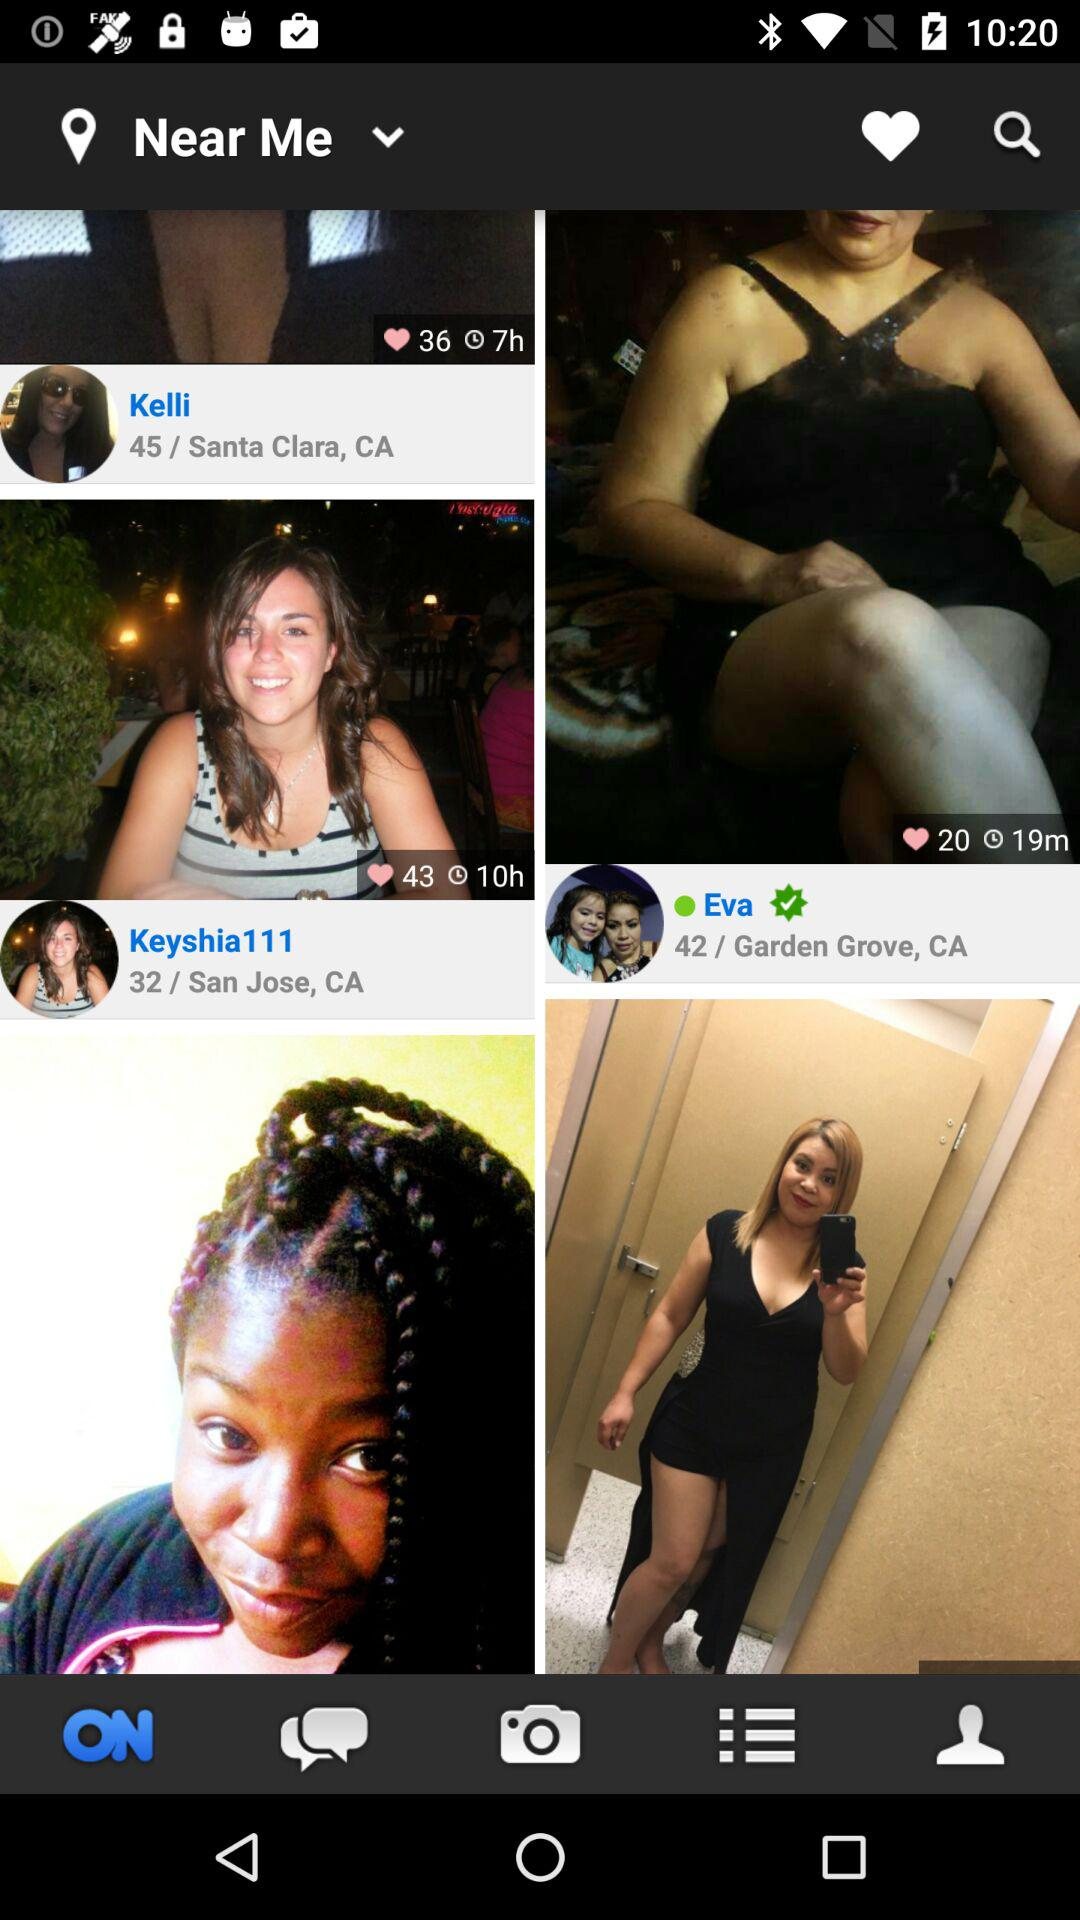How many hearts are given to Kelli? There are 36 hearts that are given to Kelli. 